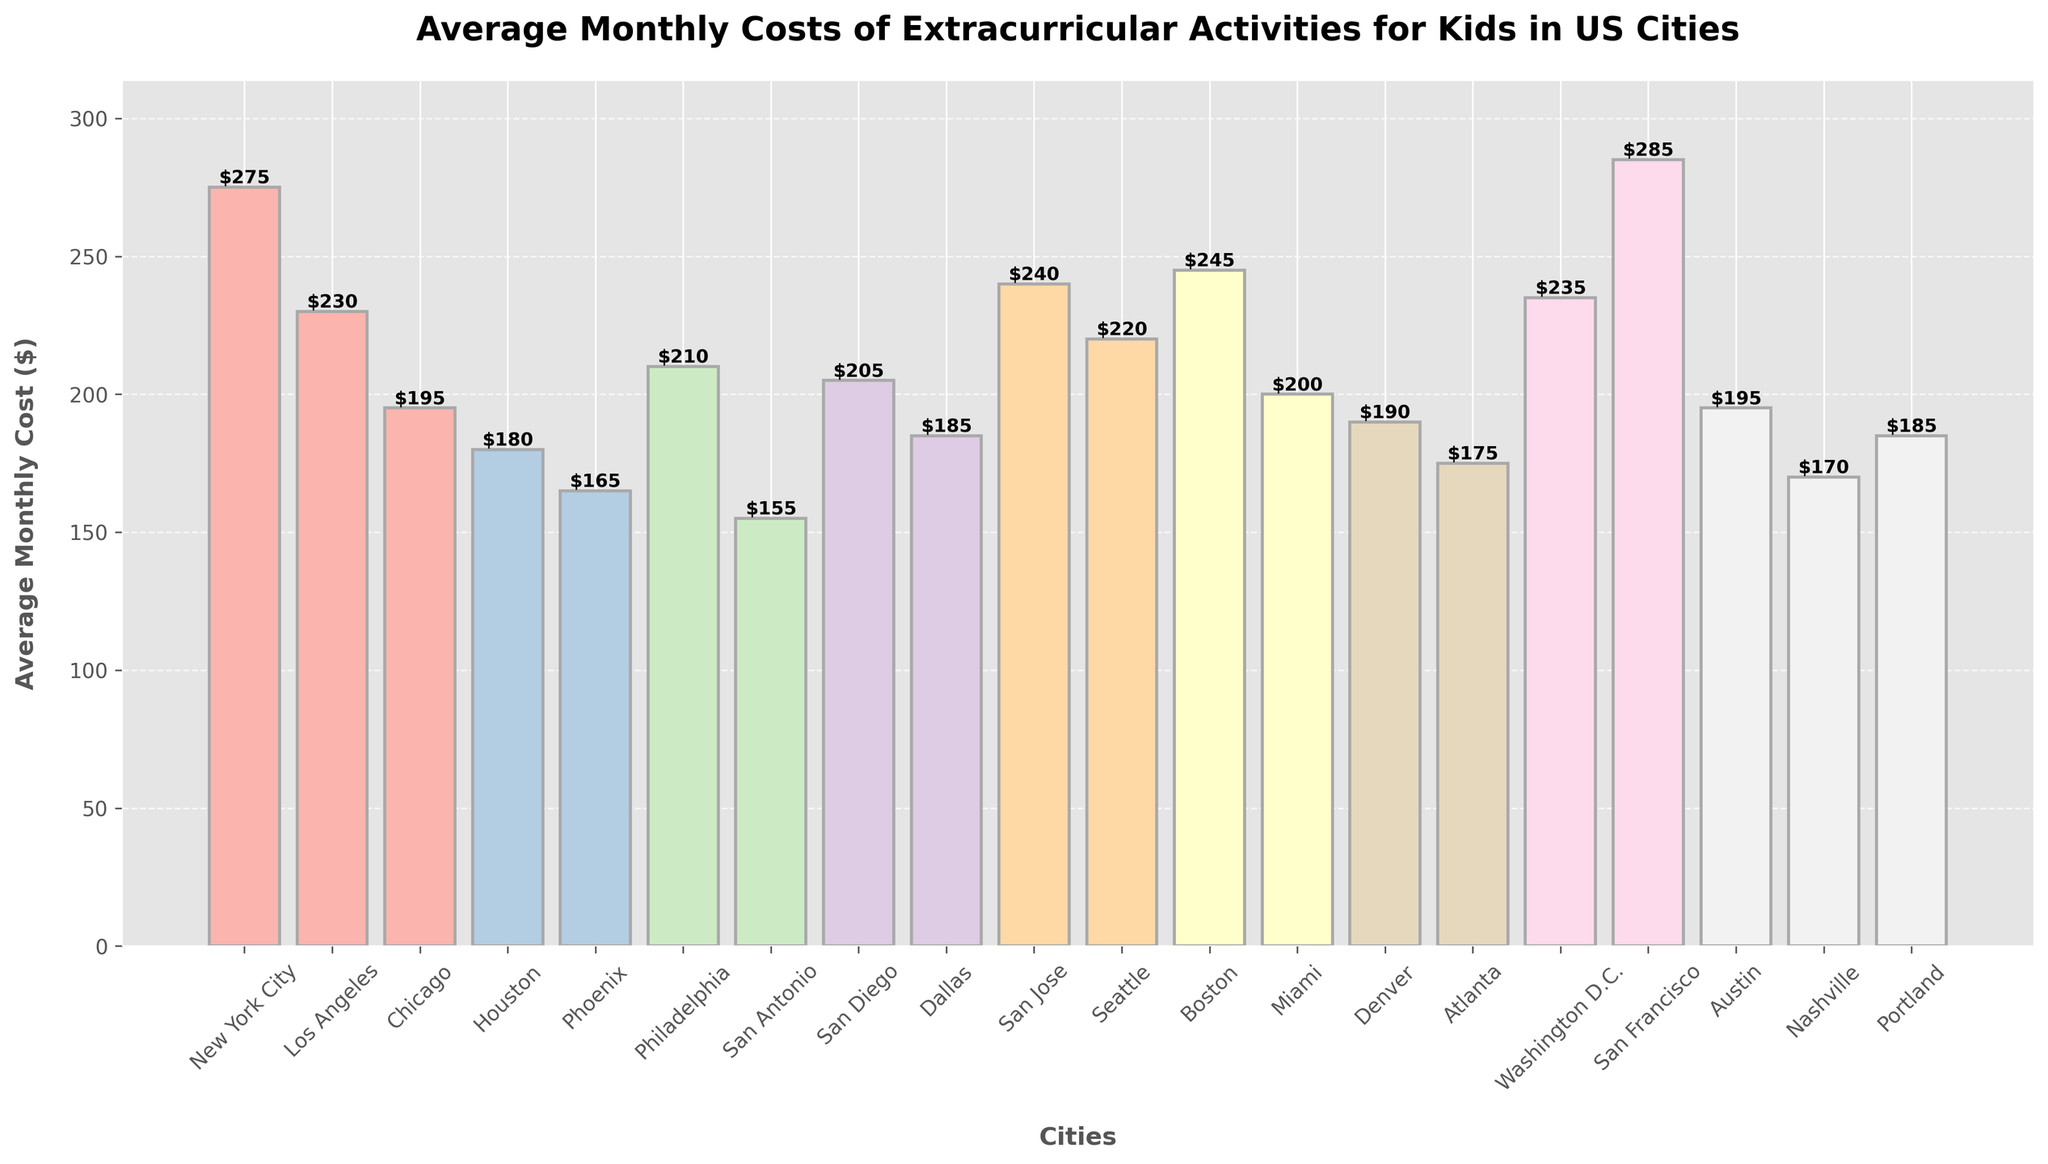Which city has the highest average monthly cost for extracurricular activities? Looking at the figure, the highest bar indicates the highest average monthly cost. According to the labelled heights, San Francisco has the highest cost of $285.
Answer: San Francisco Which city has the lowest average monthly cost for extracurricular activities? To find the lowest average monthly cost, look for the shortest bar. The lowest bar is for San Antonio, with a cost of $155.
Answer: San Antonio What is the difference in average monthly cost between New York City and Dallas? New York City's cost is $275, and Dallas's cost is $185. Calculate the difference: $275 - $185 = $90.
Answer: $90 How many cities have an average monthly cost greater than $200? Count the number of cities where the bar height is above $200. There are seven cities: New York City, Los Angeles, San Jose, Seattle, Boston, Washington D.C., and San Francisco.
Answer: 7 What is the average monthly cost for extracurricular activities in Boston, New York City, and Los Angeles? Add the costs for Boston ($245), New York City ($275), and Los Angeles ($230), then divide by 3: ($245 + $275 + $230) / 3 = $750 / 3 = $250.
Answer: $250 Which city has a higher average cost, Seattle or Miami, and by how much? Seattle's cost is $220, and Miami's cost is $200. Calculate the difference: $220 - $200 = $20.
Answer: Seattle, $20 What is the total average monthly cost of extracurricular activities for the top three cities? The top three cities are San Francisco ($285), New York City ($275), and Boston ($245). Add these values together: $285 + $275 + $245 = $805.
Answer: $805 Which city has the second lowest average monthly cost? After identifying San Antonio as the city with the lowest cost ($155), the next lowest is Phoenix with $165.
Answer: Phoenix How does the average monthly cost of extracurricular activities in Washington D.C. compare to that in Houston? Washington D.C.'s cost is $235, and Houston's cost is $180. Compare the two: $235 is greater than $180 by $55.
Answer: $55 What’s the combined average monthly cost for New York City and Chicago? Add the costs for New York City ($275) and Chicago ($195): $275 + $195 = $470.
Answer: $470 